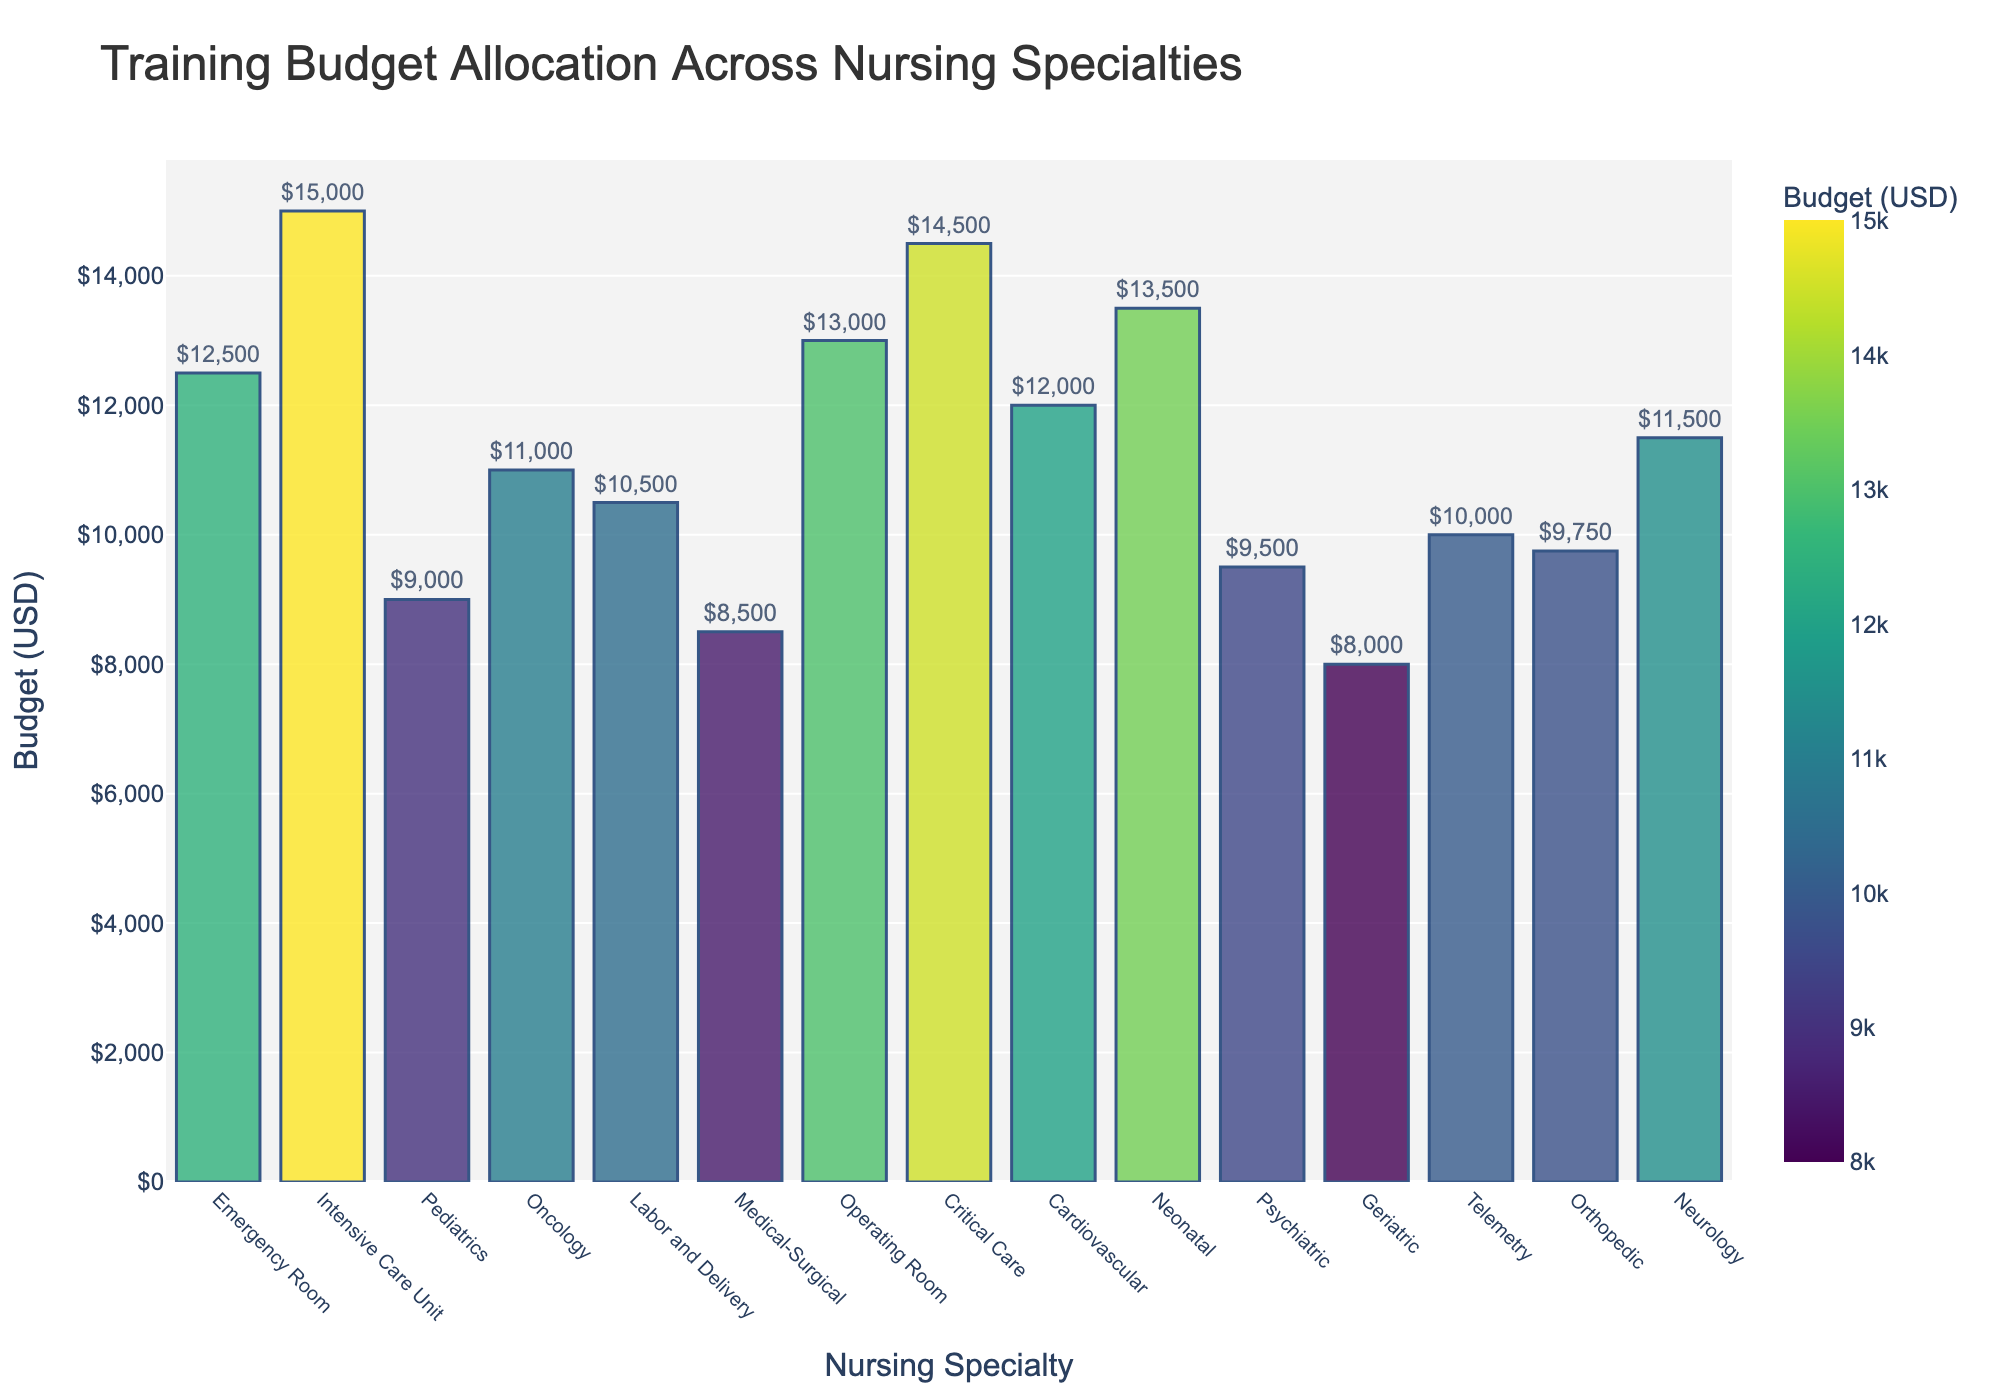What is the highest training budget allocation among the nursing specialties? The highest bar in the bar chart signifies the largest budget. By inspecting the chart, the Intensive Care Unit has the highest bar.
Answer: $15,000 Which nursing specialty has the lowest training budget allocation? By identifying the shortest bar in the chart, we can see that the Geriatric specialty has the lowest training budget allocation.
Answer: $8,000 How much more is allocated to the Intensive Care Unit compared to the Medical-Surgical specialty? The budget for Intensive Care Unit is $15,000 and for Medical-Surgical it is $8,500. Subtracting these values gives $15,000 - $8,500.
Answer: $6,500 What is the average training budget allocation across all nursing specialties? Sum all the budget allocations and divide by the number of specialties: (12500 + 15000 + 9000 + 11000 + 10500 + 8500 + 13000 + 14500 + 12000 + 13500 + 9500 + 8000 + 10000 + 9750 + 11500) / 15
Answer: $11,016.67 Which two nursing specialties have the closest training budget allocations? By comparing the values visually and numerically, we notice that the Training Budget Allocations for Orthopedic ($9,750) and Pediatric ($9,000) are closest. The difference is $9,750 - $9,000.
Answer: Pediatrics and Orthopedic What is the combined training budget for Cardiovascular and Neonatal specialties? The budget for Cardiovascular is $12,000 and for Neonatal it is $13,500. Adding these two gives $12,000 + $13,500.
Answer: $25,500 How much less is allocated to Oncology compared to Operating Room? The budget for Oncology is $11,000 and for Operating Room it is $13,000. Subtracting these values gives $13,000 - $11,000.
Answer: $2,000 What is the total budget allocation for specialties with more than $12,000 each? Specialties with budgets over $12,000 are Intensive Care Unit ($15,000), Critical Care ($14,500), Neonatal ($13,500), and Operating Room ($13,000). Summing these values gives $15,000 + $14,500 + $13,500 + $13,000
Answer: $56,000 What is the difference in training budget allocation between the Emergency Room and the Neurology specialty? The budget for Emergency Room is $12,500 and for Neurology it is $11,500. Subtracting these values gives $12,500 - $11,500.
Answer: $1,000 How does the budget for Geriatric compare to that of Telemetry? The budget for Geriatric is $8,000 and for Telemetry it is $10,000. Comparing these, Geriatric is less than Telemetry by $10,000 - $8,000.
Answer: $2,000 